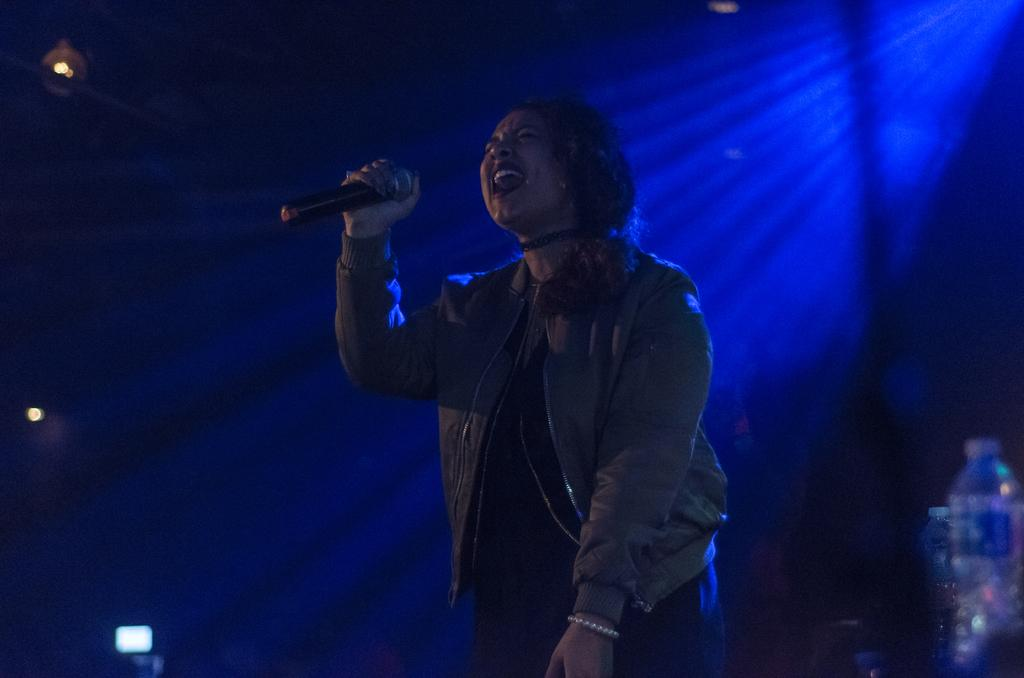Who is present in the image? There is a woman in the image. What is the woman holding in the image? The woman is holding a microphone. What other object can be seen in the image? There is a bottle in the image. What type of yoke is being used by the woman in the image? There is no yoke present in the image. Are there any police officers visible in the image? There is no indication of any police officers in the image. 